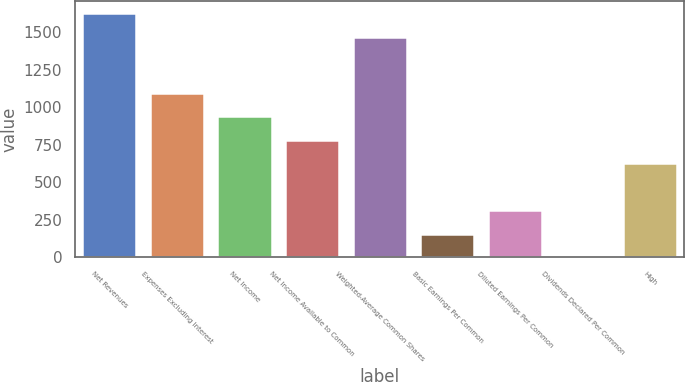Convert chart. <chart><loc_0><loc_0><loc_500><loc_500><bar_chart><fcel>Net Revenues<fcel>Expenses Excluding Interest<fcel>Net Income<fcel>Net Income Available to Common<fcel>Weighted-Average Common Shares<fcel>Basic Earnings Per Common<fcel>Diluted Earnings Per Common<fcel>Dividends Declared Per Common<fcel>High<nl><fcel>1627.18<fcel>1096.19<fcel>939.6<fcel>783.01<fcel>1470.59<fcel>156.65<fcel>313.24<fcel>0.06<fcel>626.42<nl></chart> 